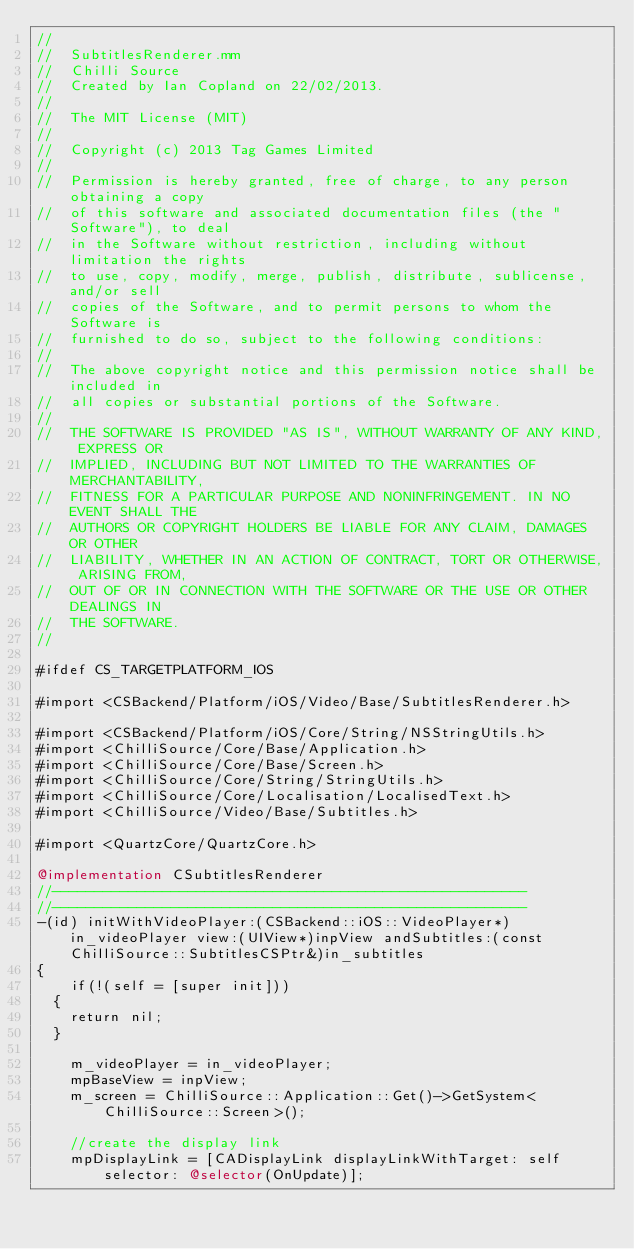<code> <loc_0><loc_0><loc_500><loc_500><_ObjectiveC_>//
//  SubtitlesRenderer.mm
//  Chilli Source
//  Created by Ian Copland on 22/02/2013.
//
//  The MIT License (MIT)
//
//  Copyright (c) 2013 Tag Games Limited
//
//  Permission is hereby granted, free of charge, to any person obtaining a copy
//  of this software and associated documentation files (the "Software"), to deal
//  in the Software without restriction, including without limitation the rights
//  to use, copy, modify, merge, publish, distribute, sublicense, and/or sell
//  copies of the Software, and to permit persons to whom the Software is
//  furnished to do so, subject to the following conditions:
//
//  The above copyright notice and this permission notice shall be included in
//  all copies or substantial portions of the Software.
//
//  THE SOFTWARE IS PROVIDED "AS IS", WITHOUT WARRANTY OF ANY KIND, EXPRESS OR
//  IMPLIED, INCLUDING BUT NOT LIMITED TO THE WARRANTIES OF MERCHANTABILITY,
//  FITNESS FOR A PARTICULAR PURPOSE AND NONINFRINGEMENT. IN NO EVENT SHALL THE
//  AUTHORS OR COPYRIGHT HOLDERS BE LIABLE FOR ANY CLAIM, DAMAGES OR OTHER
//  LIABILITY, WHETHER IN AN ACTION OF CONTRACT, TORT OR OTHERWISE, ARISING FROM,
//  OUT OF OR IN CONNECTION WITH THE SOFTWARE OR THE USE OR OTHER DEALINGS IN
//  THE SOFTWARE.
//

#ifdef CS_TARGETPLATFORM_IOS

#import <CSBackend/Platform/iOS/Video/Base/SubtitlesRenderer.h>

#import <CSBackend/Platform/iOS/Core/String/NSStringUtils.h>
#import <ChilliSource/Core/Base/Application.h>
#import <ChilliSource/Core/Base/Screen.h>
#import <ChilliSource/Core/String/StringUtils.h>
#import <ChilliSource/Core/Localisation/LocalisedText.h>
#import <ChilliSource/Video/Base/Subtitles.h>

#import <QuartzCore/QuartzCore.h>

@implementation CSubtitlesRenderer
//--------------------------------------------------------
//--------------------------------------------------------
-(id) initWithVideoPlayer:(CSBackend::iOS::VideoPlayer*)in_videoPlayer view:(UIView*)inpView andSubtitles:(const ChilliSource::SubtitlesCSPtr&)in_subtitles
{
    if(!(self = [super init]))
	{
		return nil;
	}
    
    m_videoPlayer = in_videoPlayer;
    mpBaseView = inpView;
    m_screen = ChilliSource::Application::Get()->GetSystem<ChilliSource::Screen>();
    
    //create the display link
    mpDisplayLink = [CADisplayLink displayLinkWithTarget: self selector: @selector(OnUpdate)];</code> 